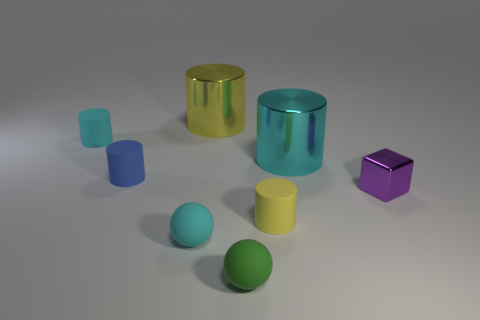Subtract all cyan rubber cylinders. How many cylinders are left? 4 Subtract all blue cylinders. How many cylinders are left? 4 Subtract all green cylinders. Subtract all brown spheres. How many cylinders are left? 5 Add 1 small blue things. How many objects exist? 9 Subtract all cubes. How many objects are left? 7 Add 1 tiny green matte things. How many tiny green matte things exist? 2 Subtract 0 green blocks. How many objects are left? 8 Subtract all yellow matte cylinders. Subtract all tiny balls. How many objects are left? 5 Add 8 cubes. How many cubes are left? 9 